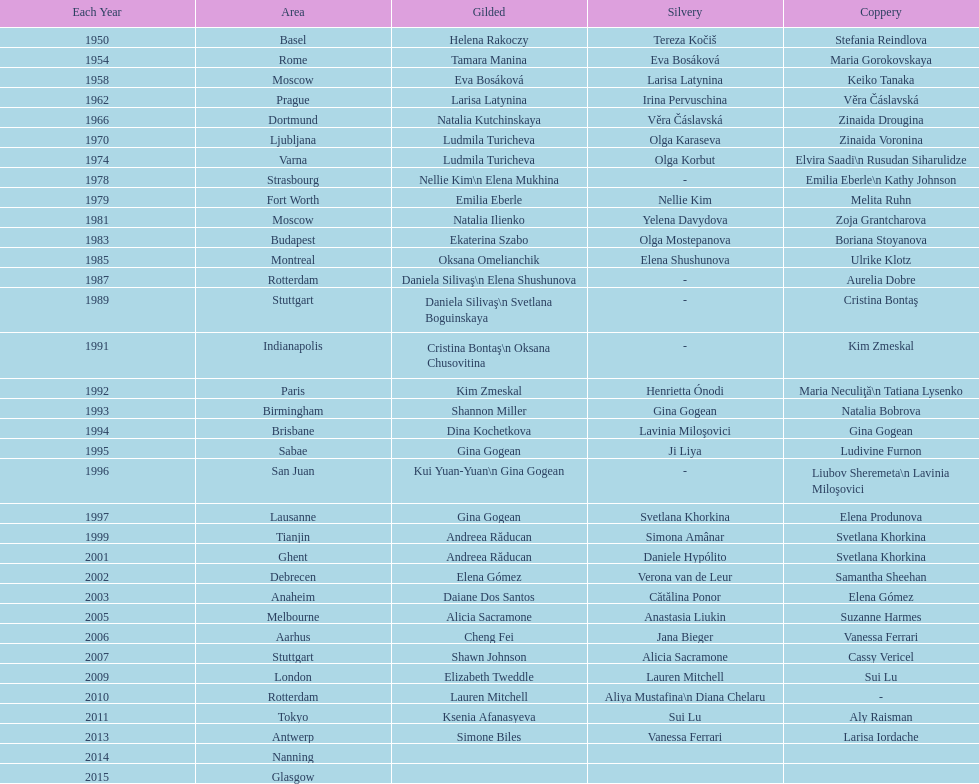Where were the championships held before the 1962 prague championships? Moscow. 